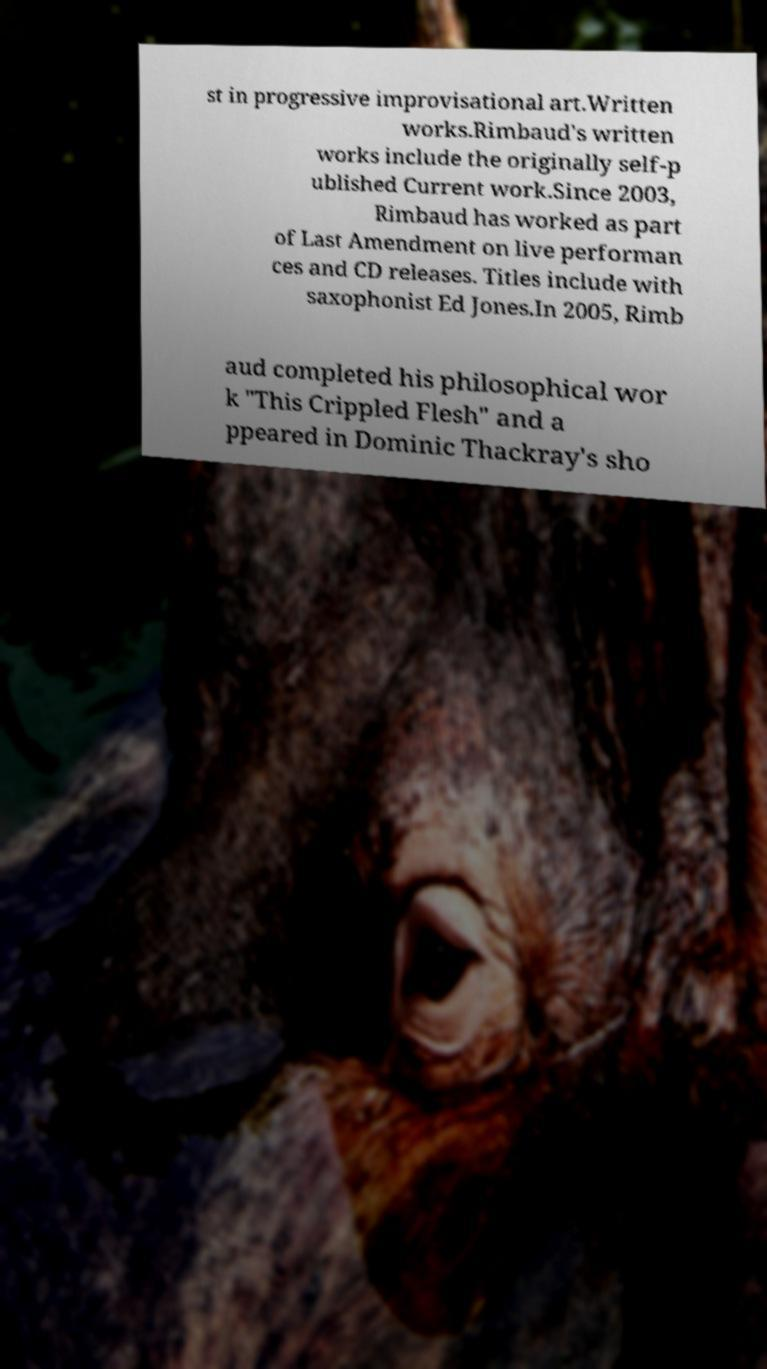Could you assist in decoding the text presented in this image and type it out clearly? st in progressive improvisational art.Written works.Rimbaud's written works include the originally self-p ublished Current work.Since 2003, Rimbaud has worked as part of Last Amendment on live performan ces and CD releases. Titles include with saxophonist Ed Jones.In 2005, Rimb aud completed his philosophical wor k "This Crippled Flesh" and a ppeared in Dominic Thackray's sho 